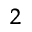Convert formula to latex. <formula><loc_0><loc_0><loc_500><loc_500>^ { 2 }</formula> 